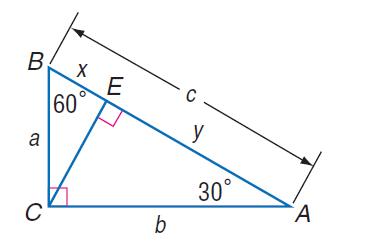Answer the mathemtical geometry problem and directly provide the correct option letter.
Question: If a = 10 \sqrt { 3 }, find y.
Choices: A: 10 B: 15 C: 10 \sqrt { 3 } D: 15 \sqrt { 3 } D 